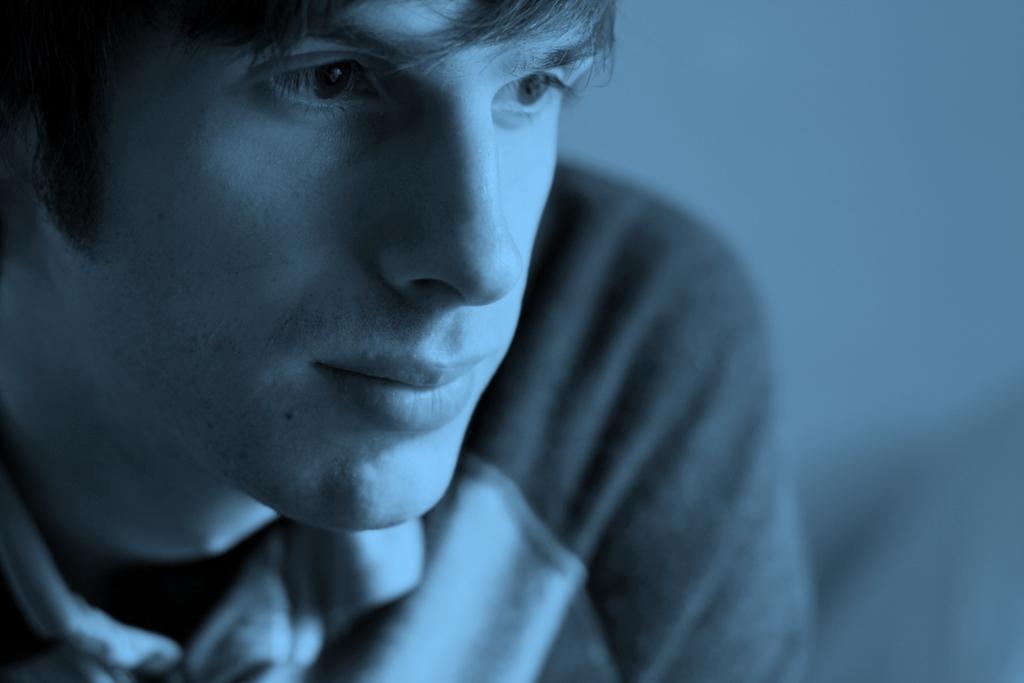Please provide a concise description of this image. In this image we can see the close view of a person wearing T-shirt. This part of the image is slightly blurred. 